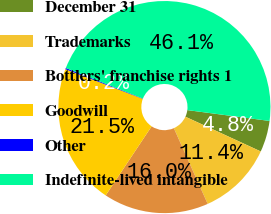Convert chart. <chart><loc_0><loc_0><loc_500><loc_500><pie_chart><fcel>December 31<fcel>Trademarks<fcel>Bottlers' franchise rights 1<fcel>Goodwill<fcel>Other<fcel>Indefinite-lived intangible<nl><fcel>4.78%<fcel>11.44%<fcel>16.03%<fcel>21.47%<fcel>0.19%<fcel>46.08%<nl></chart> 